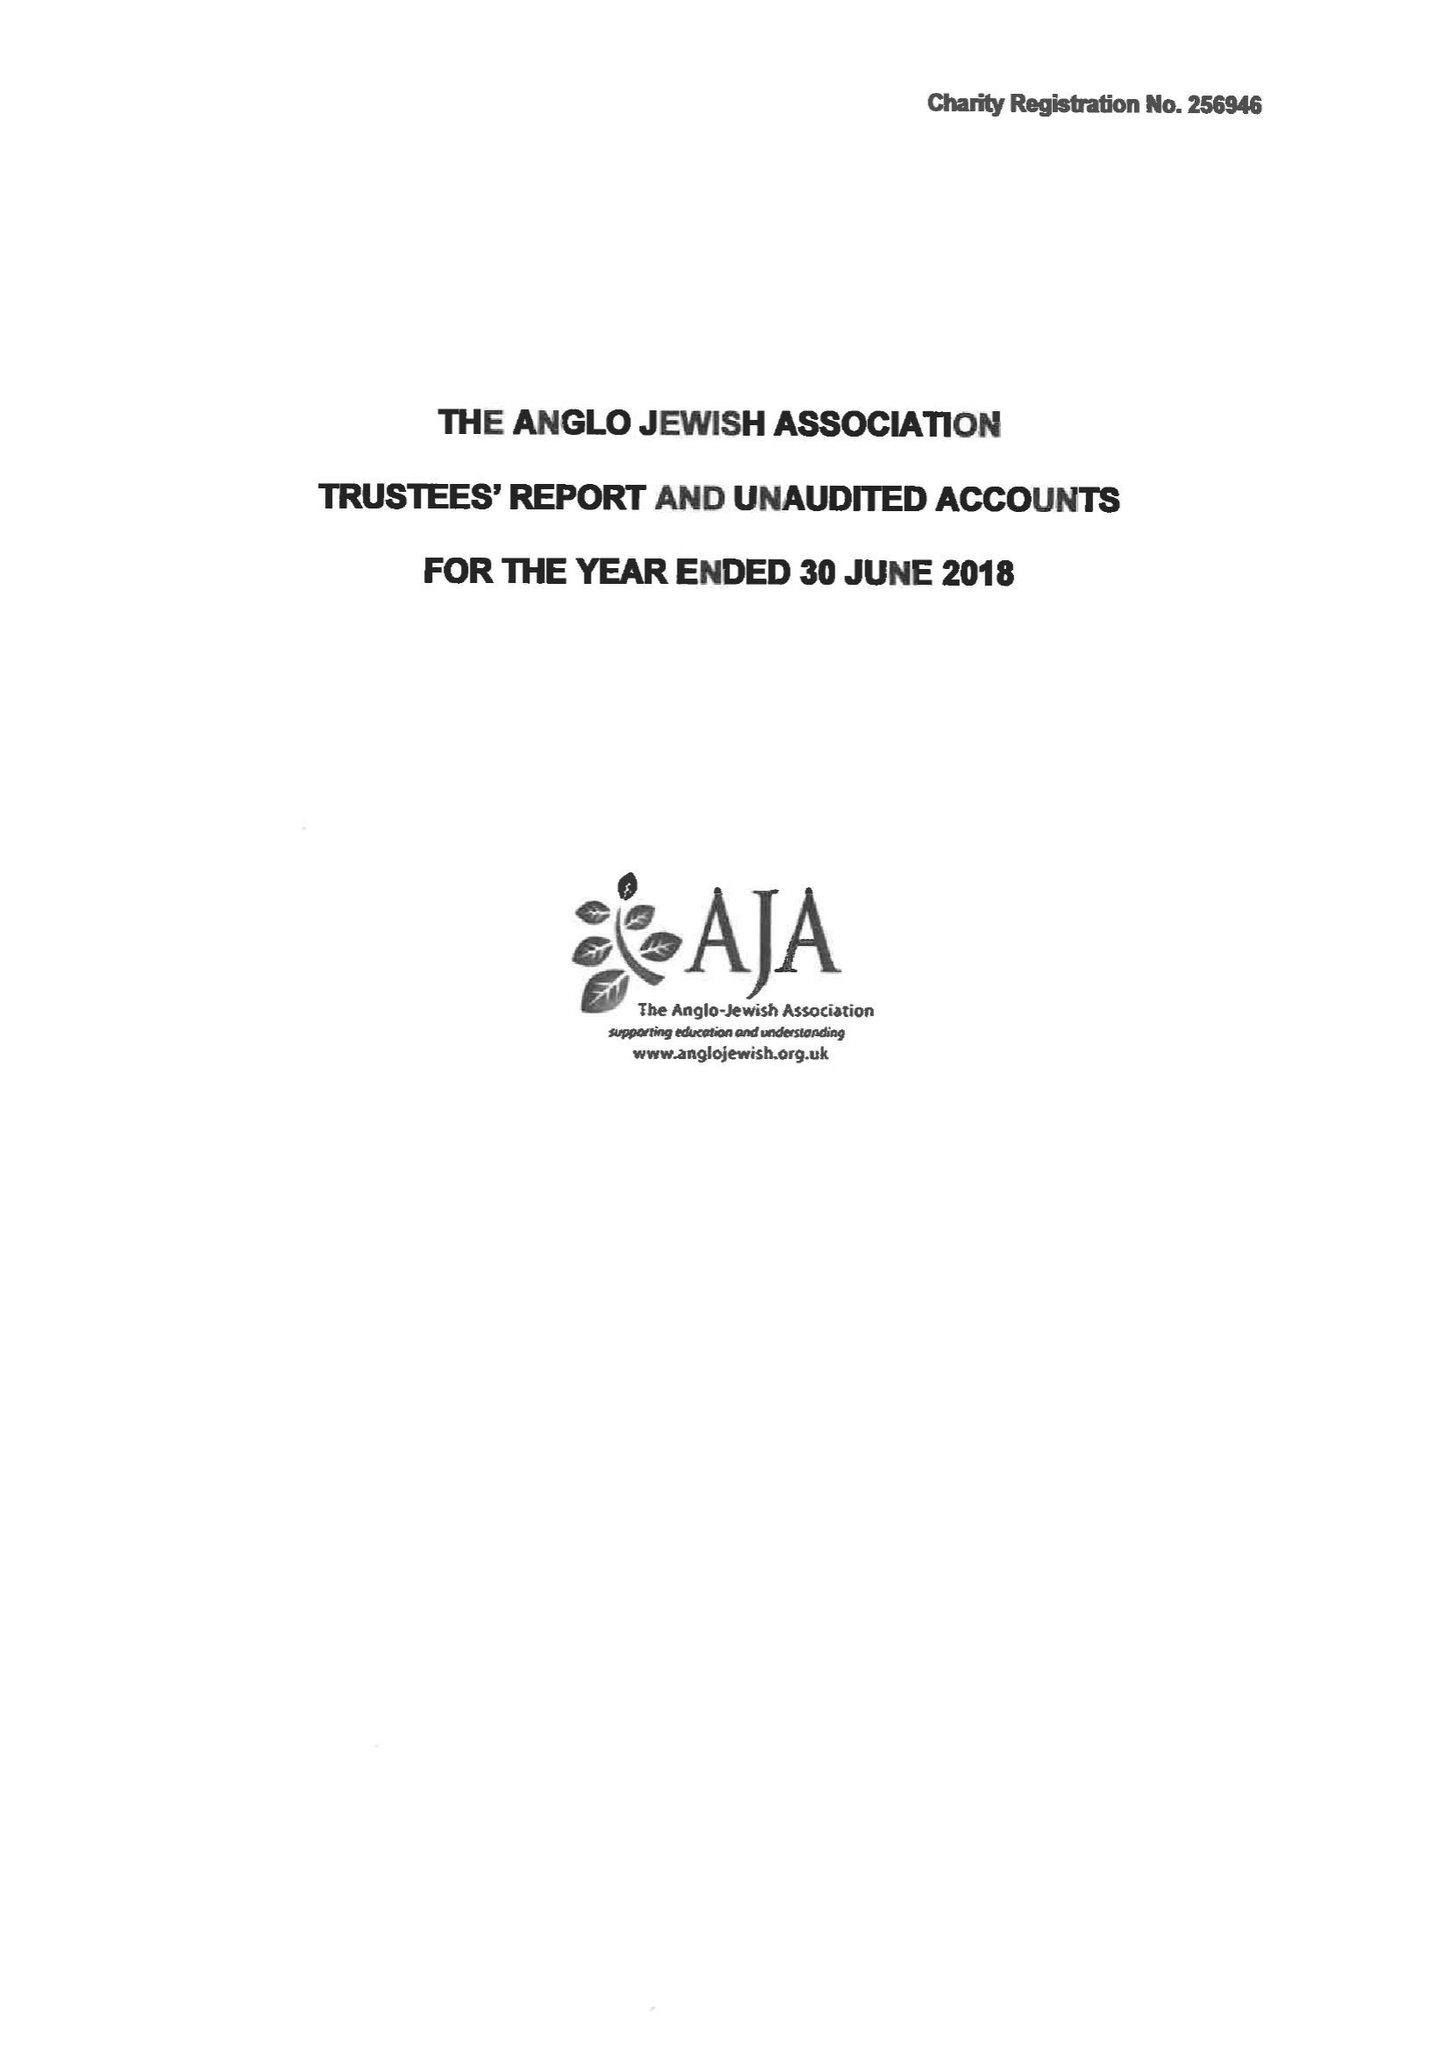What is the value for the report_date?
Answer the question using a single word or phrase. 2018-06-30 